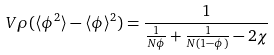<formula> <loc_0><loc_0><loc_500><loc_500>V \rho ( \langle \phi ^ { 2 } \rangle - \langle \phi \rangle ^ { 2 } ) = \frac { 1 } { \frac { 1 } { N \phi } + \frac { 1 } { N ( 1 - \phi ) } - 2 \chi }</formula> 